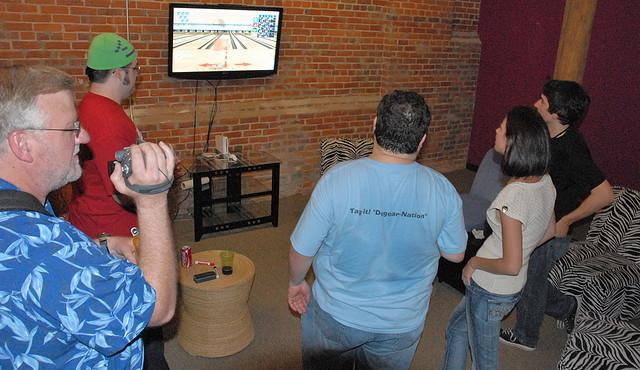Which Wii sport game must be played by the crowd of children in the lounge?

Choices:
A) golf
B) boxing
C) tennis
D) bowling bowling 